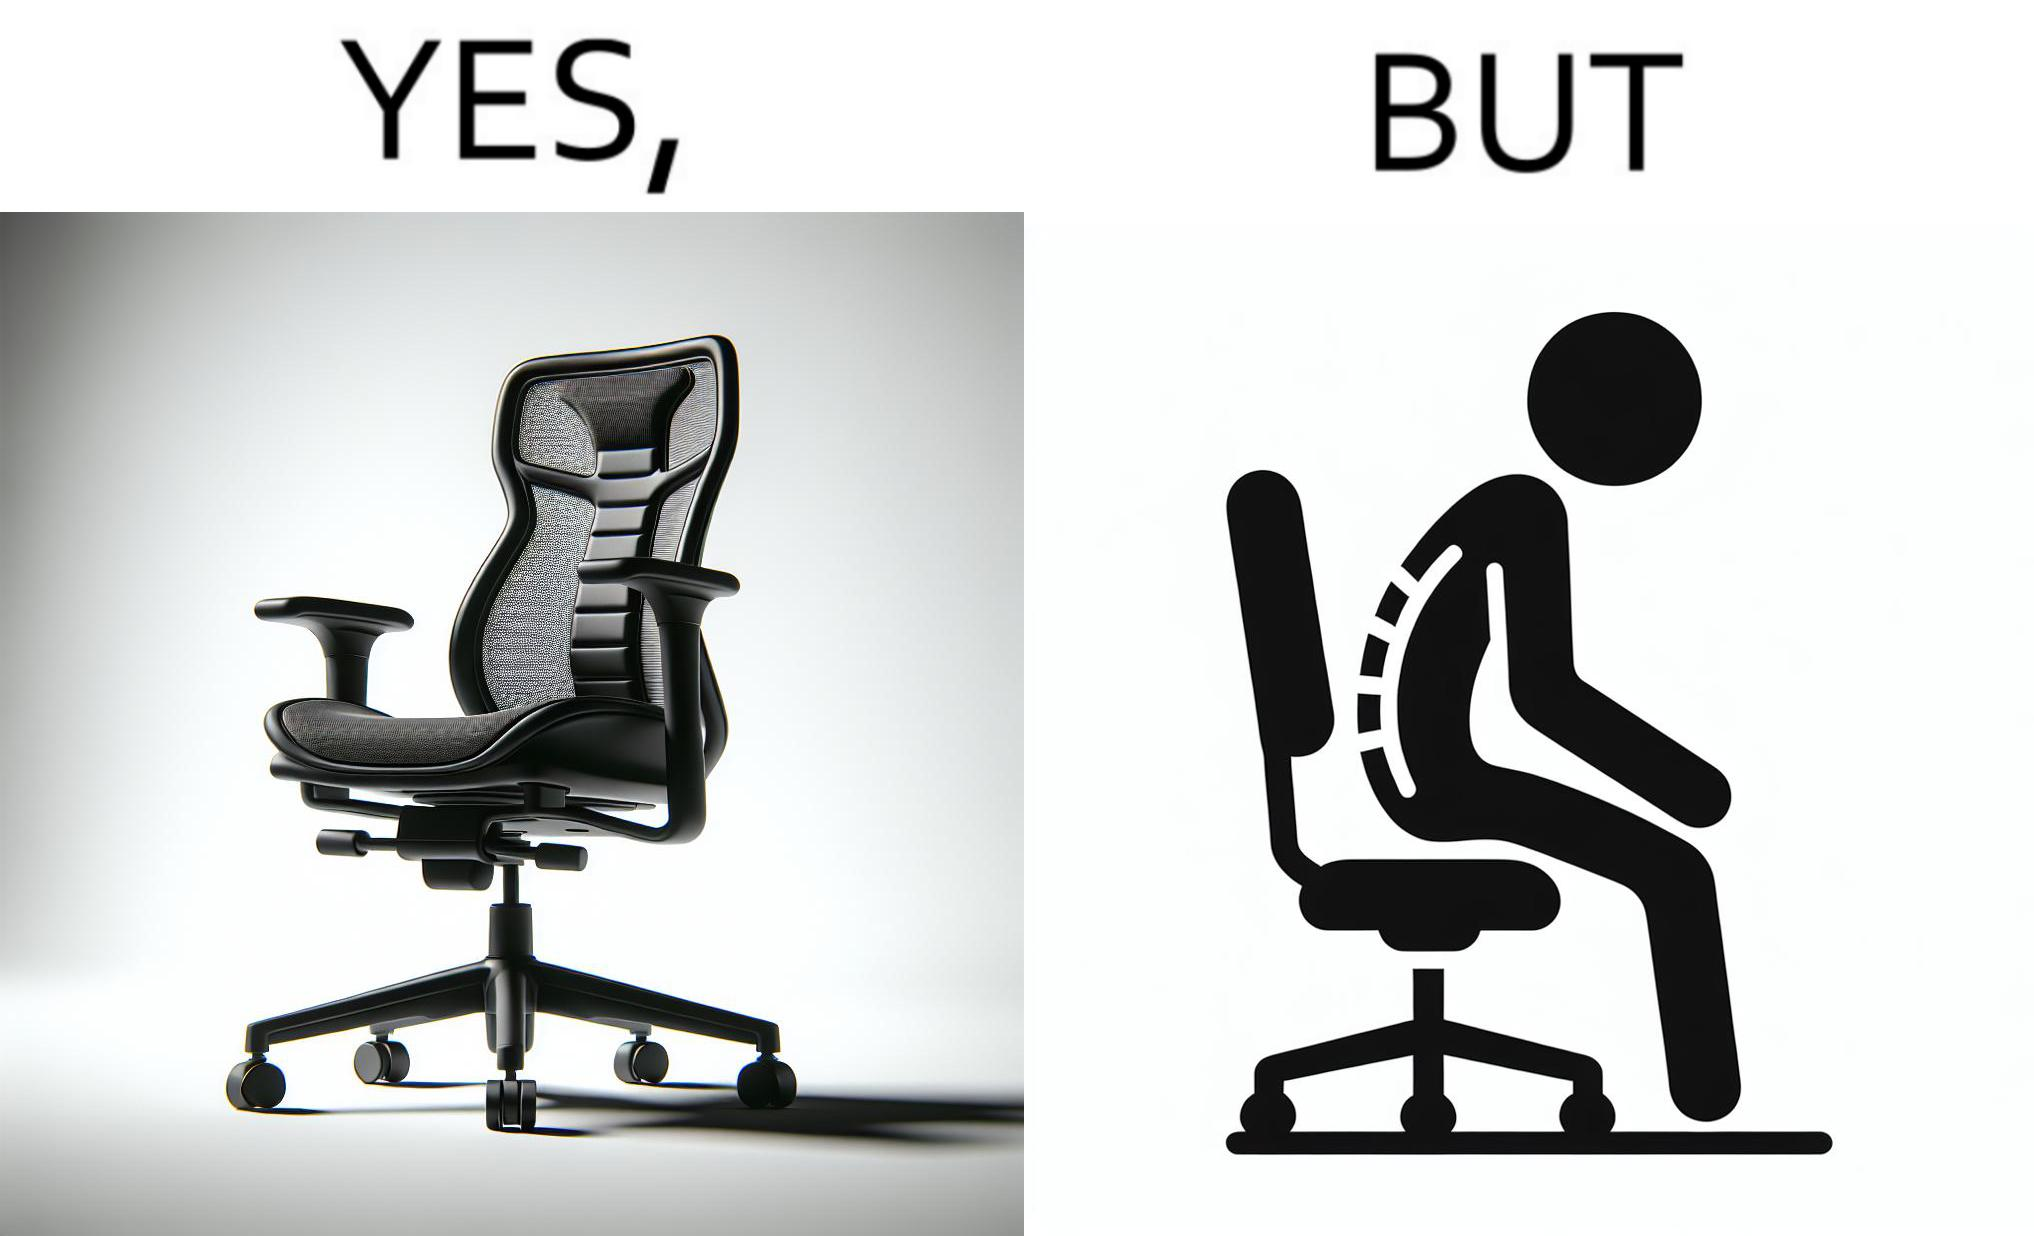Would you classify this image as satirical? Yes, this image is satirical. 